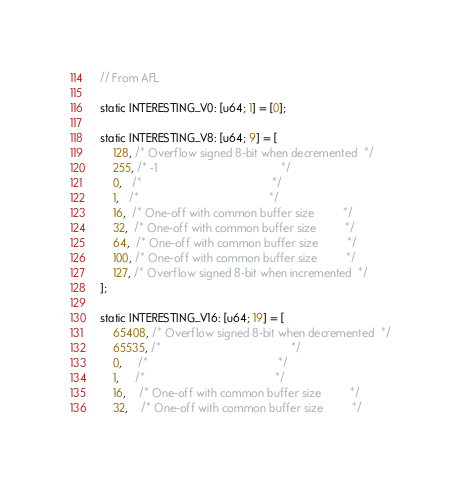Convert code to text. <code><loc_0><loc_0><loc_500><loc_500><_Rust_>// From AFL

static INTERESTING_V0: [u64; 1] = [0];

static INTERESTING_V8: [u64; 9] = [
    128, /* Overflow signed 8-bit when decremented  */
    255, /* -1                                       */
    0,   /*                                         */
    1,   /*                                         */
    16,  /* One-off with common buffer size         */
    32,  /* One-off with common buffer size         */
    64,  /* One-off with common buffer size         */
    100, /* One-off with common buffer size         */
    127, /* Overflow signed 8-bit when incremented  */
];

static INTERESTING_V16: [u64; 19] = [
    65408, /* Overflow signed 8-bit when decremented  */
    65535, /*                                         */
    0,     /*                                         */
    1,     /*                                         */
    16,    /* One-off with common buffer size         */
    32,    /* One-off with common buffer size         */</code> 